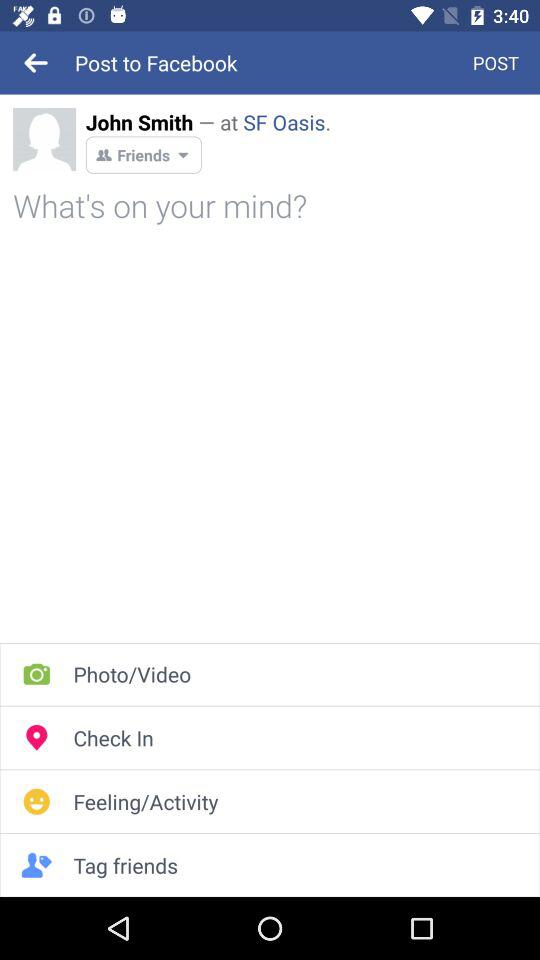What is the profile name? The profile name is John Smith. 